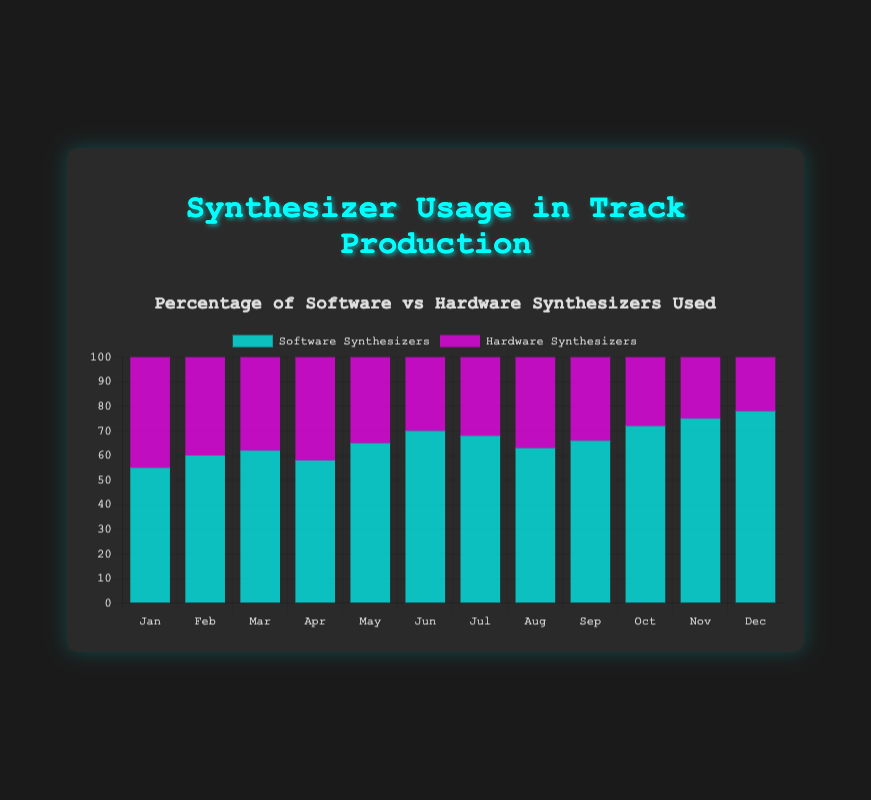How has the usage of software synthesizers changed from January to December? Look at the height of the light blue bars representing software synthesizers for January and December. In January, the bar is at 55%, and in December, it is at 78%. Thus, the usage increased from 55% to 78%.
Answer: Increased from 55% to 78% Which month had the highest percentage of hardware synthesizer usage? Look at the pink bars representing hardware synthesizers across all months. The highest bar is for January, at 45%.
Answer: January What is the difference in the usage percentage of software synthesizers between June and August? Find the light blue bars for June (70%) and August (63%). Subtract the percentage of August from June (70 - 63 = 7).
Answer: 7% On average, which synthesizer type had a higher percentage usage over the year? Calculate the average for both synthesizers. For software: (55+60+62+58+65+70+68+63+66+72+75+78)/12 =67. For hardware: (45+40+38+42+35+30+32+37+34+28+25+22)/12 = 33.5. Software has a higher average.
Answer: Software synthesizers Which month showed the most balanced usage between software and hardware synthesizers? Look for the month where the light blue and pink bars are closest in height. April with 58% software and 42% hardware (difference of 16%) is the most balanced.
Answer: April How does the ratio of software to hardware synthesizers change from May to November? For May: 65/35 = 1.86. For November: 75/25 = 3. Calculate the ratio for each month and compare. The ratio of software to hardware synthesizers increased from 1.86 in May to 3 in November.
Answer: Increased Which synthesizer type showed a consistent increase in usage over the year? Observe the trend of both light blue and pink bars. The light blue bars for software synthesizers increase consistently over the months, while the pink bars for hardware synthesizers show a decrease.
Answer: Software synthesizers In which month was the difference between software and hardware synthesizer usage the largest? Calculate the differences for each month: the highest difference is in December, with software at 78% and hardware at 22% (difference of 56%).
Answer: December 